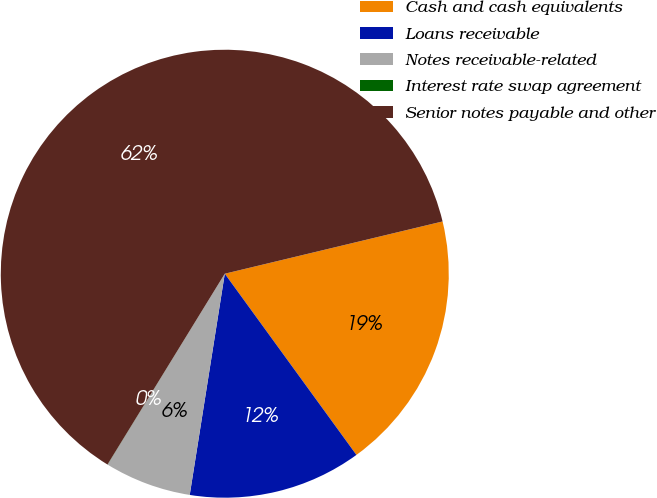<chart> <loc_0><loc_0><loc_500><loc_500><pie_chart><fcel>Cash and cash equivalents<fcel>Loans receivable<fcel>Notes receivable-related<fcel>Interest rate swap agreement<fcel>Senior notes payable and other<nl><fcel>18.75%<fcel>12.5%<fcel>6.26%<fcel>0.01%<fcel>62.48%<nl></chart> 